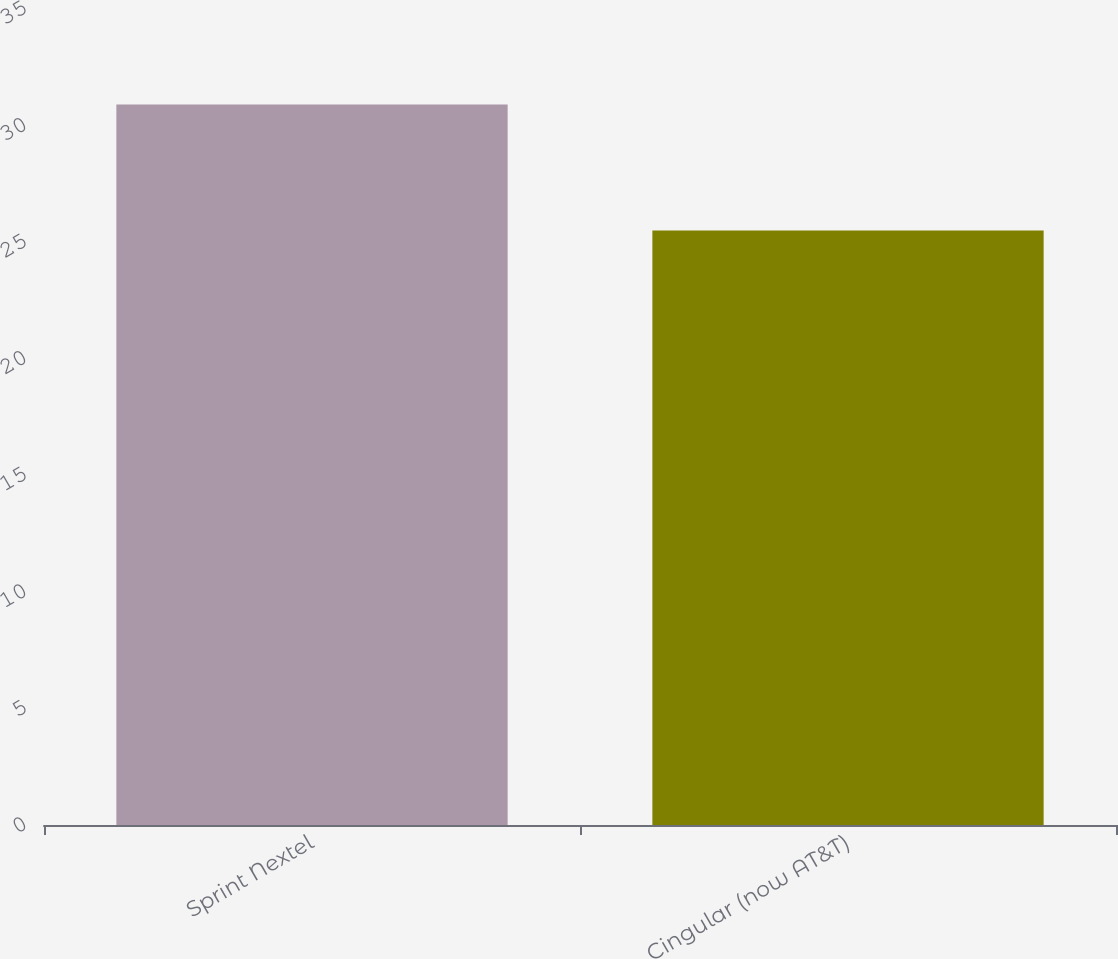Convert chart. <chart><loc_0><loc_0><loc_500><loc_500><bar_chart><fcel>Sprint Nextel<fcel>Cingular (now AT&T)<nl><fcel>30.9<fcel>25.5<nl></chart> 